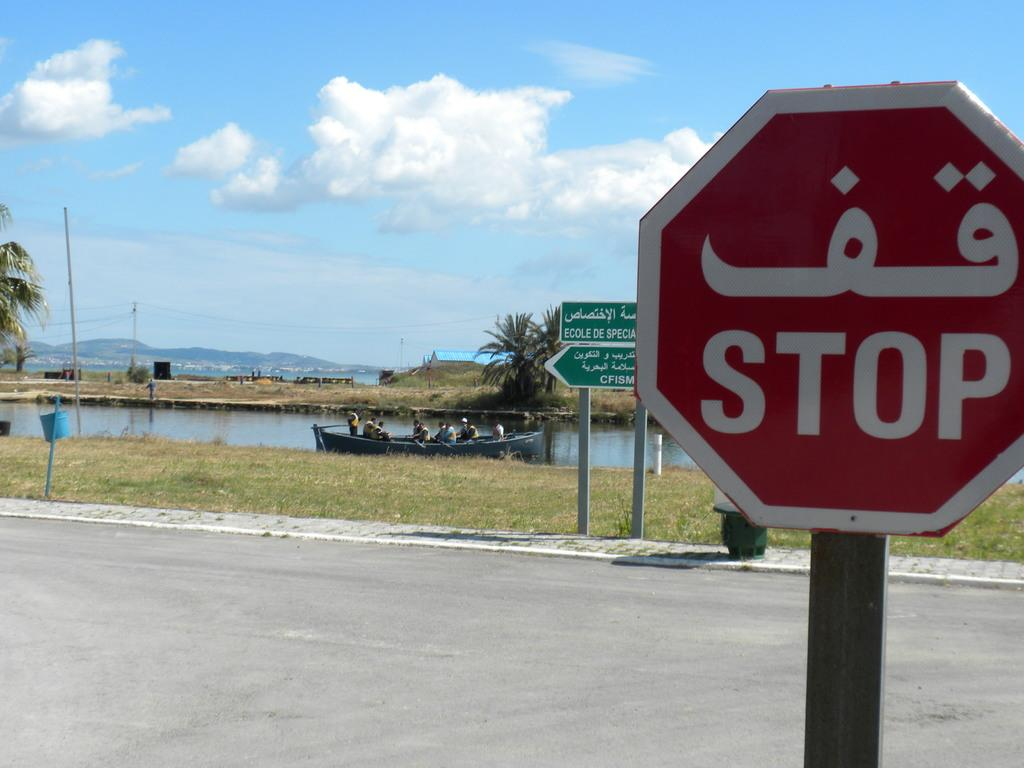<image>
Write a terse but informative summary of the picture. A stop sign is on the street with men in a boat in some water in the background. 